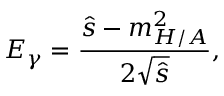Convert formula to latex. <formula><loc_0><loc_0><loc_500><loc_500>E _ { \gamma } = \frac { \hat { s } - m _ { H / A } ^ { 2 } } { 2 \sqrt { \hat { s } } } ,</formula> 